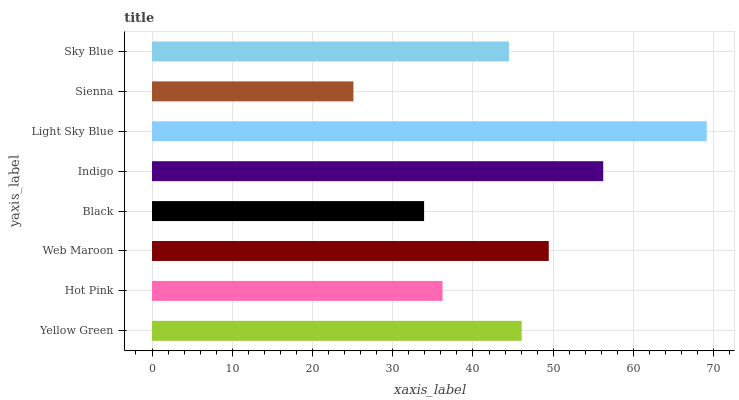Is Sienna the minimum?
Answer yes or no. Yes. Is Light Sky Blue the maximum?
Answer yes or no. Yes. Is Hot Pink the minimum?
Answer yes or no. No. Is Hot Pink the maximum?
Answer yes or no. No. Is Yellow Green greater than Hot Pink?
Answer yes or no. Yes. Is Hot Pink less than Yellow Green?
Answer yes or no. Yes. Is Hot Pink greater than Yellow Green?
Answer yes or no. No. Is Yellow Green less than Hot Pink?
Answer yes or no. No. Is Yellow Green the high median?
Answer yes or no. Yes. Is Sky Blue the low median?
Answer yes or no. Yes. Is Web Maroon the high median?
Answer yes or no. No. Is Black the low median?
Answer yes or no. No. 